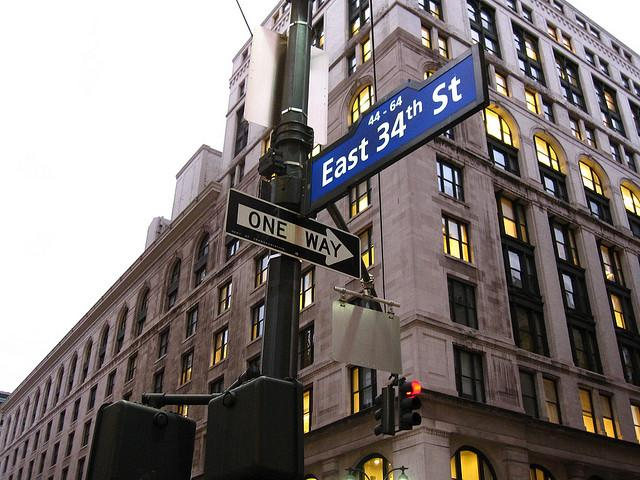What are is the image from? Please explain your reasoning. city. The image is a city. 